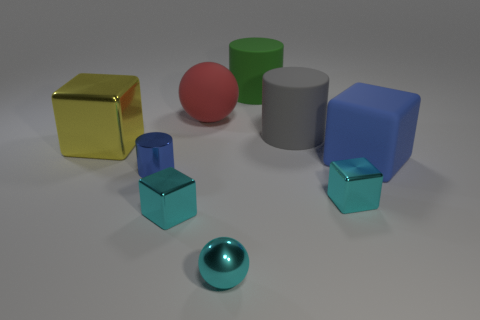The object that is the same color as the rubber cube is what shape?
Provide a succinct answer. Cylinder. Are there any large green objects that have the same material as the green cylinder?
Make the answer very short. No. How many shiny objects are blue objects or small cyan balls?
Keep it short and to the point. 2. What shape is the thing that is behind the ball behind the big rubber cube?
Offer a terse response. Cylinder. Are there fewer spheres in front of the blue cylinder than tiny gray cylinders?
Ensure brevity in your answer.  No. What shape is the large gray thing?
Offer a terse response. Cylinder. What size is the sphere in front of the small blue shiny cylinder?
Provide a succinct answer. Small. What color is the shiny block that is the same size as the rubber sphere?
Offer a very short reply. Yellow. Are there any small things of the same color as the large rubber cube?
Ensure brevity in your answer.  Yes. Are there fewer small spheres to the right of the big blue matte object than tiny cyan objects that are left of the red ball?
Make the answer very short. Yes. 